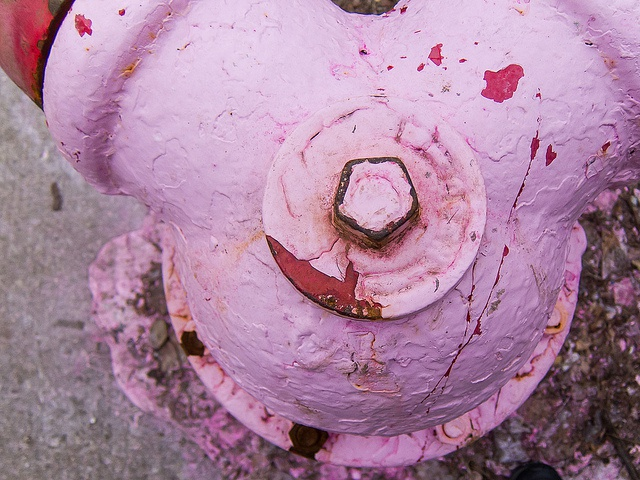Describe the objects in this image and their specific colors. I can see a fire hydrant in brown, pink, and violet tones in this image. 